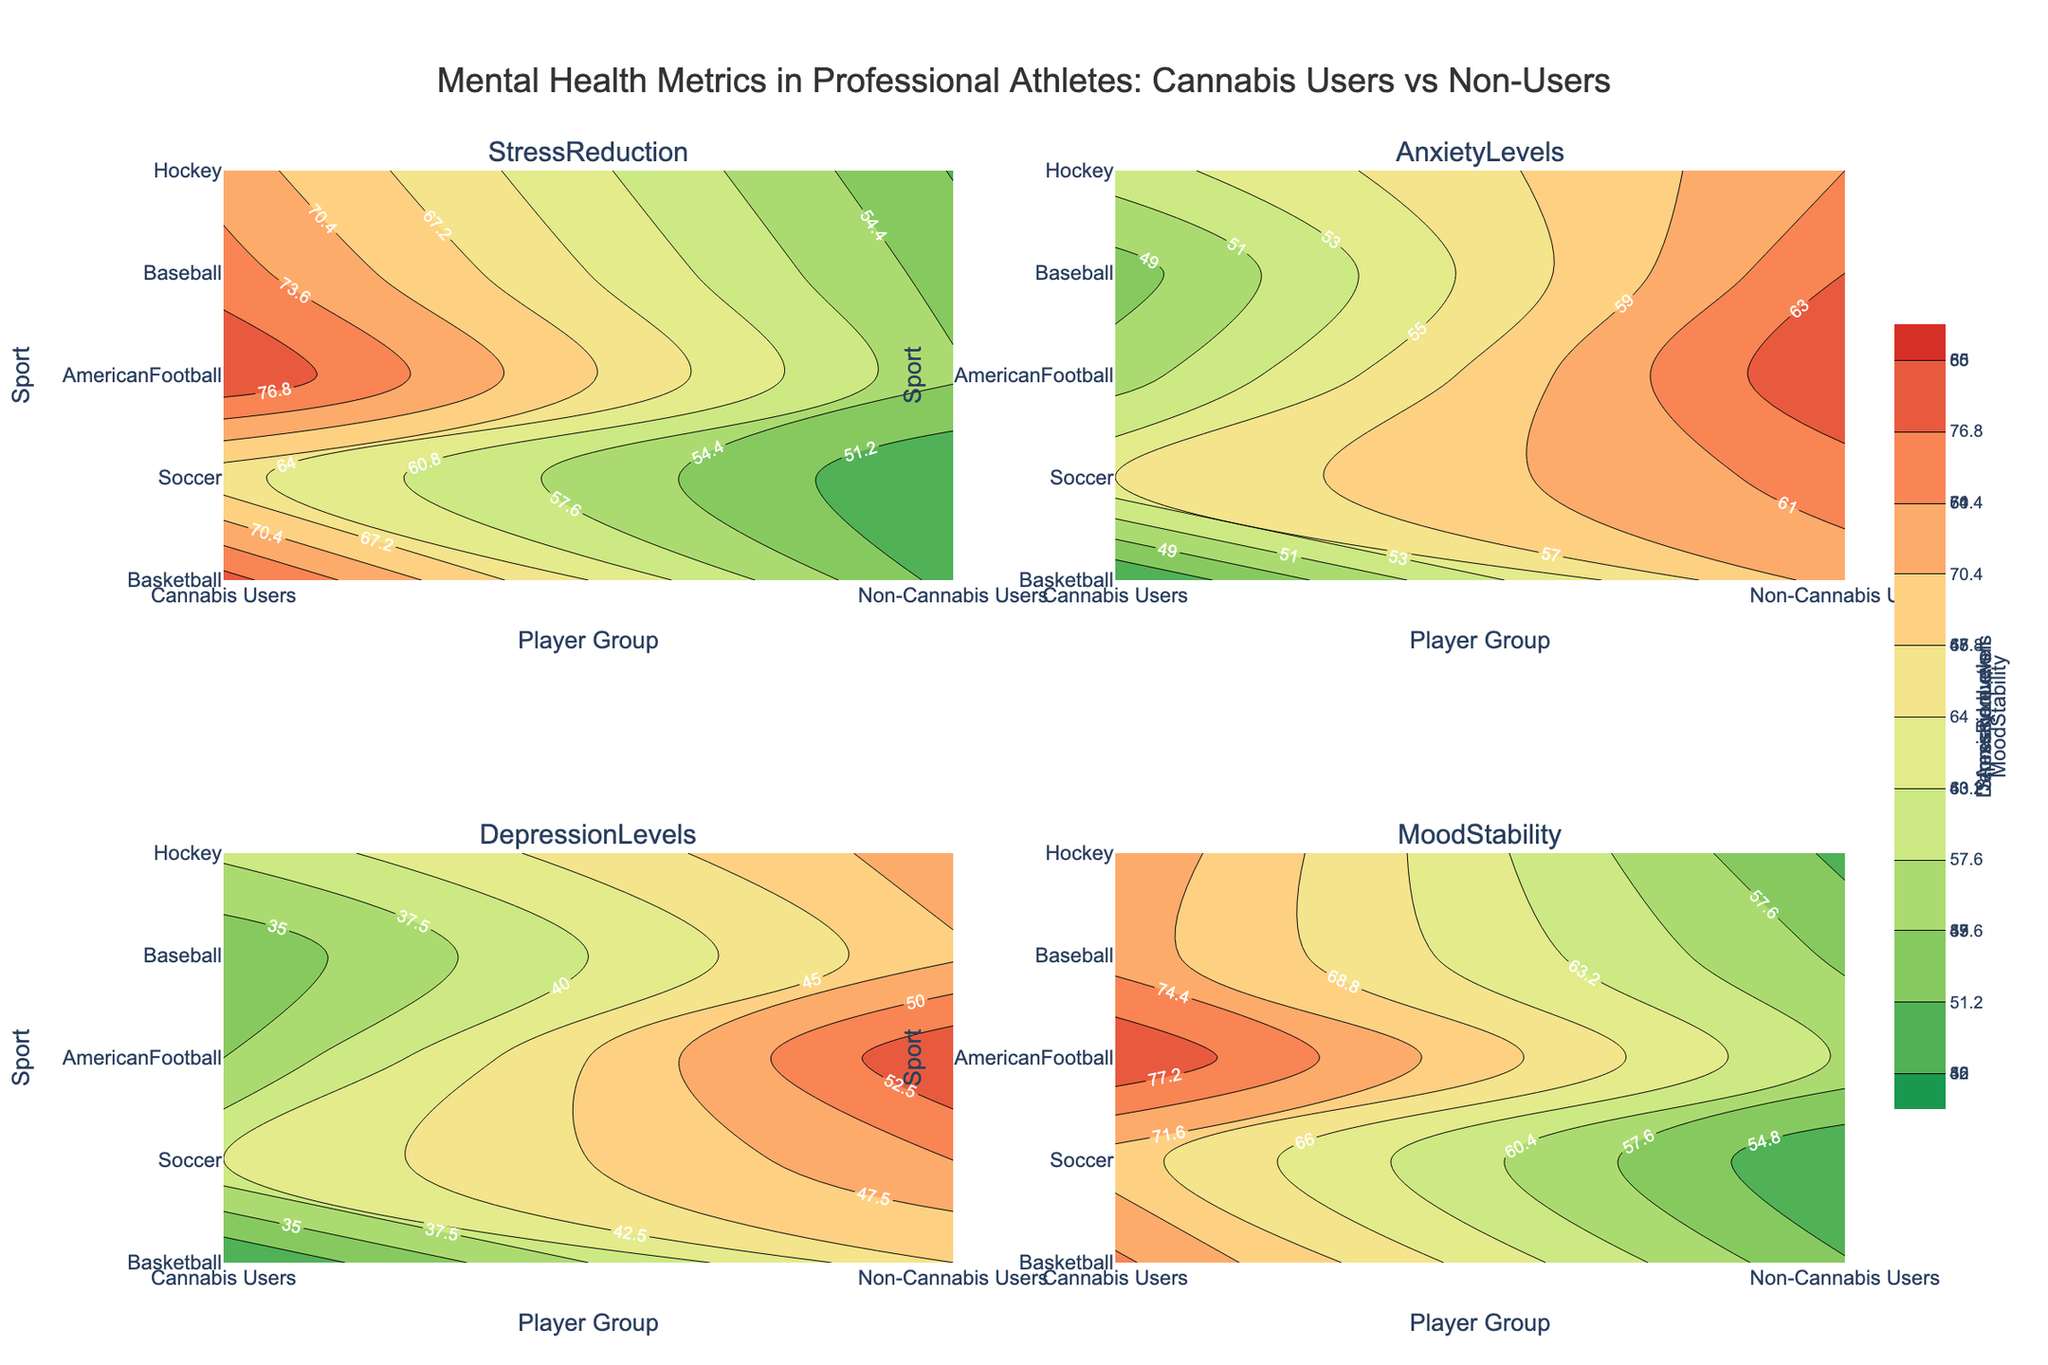What are the four mental health metrics shown in the figure? The figure has subplot titles showing four metrics related to mental health. They are Stress Reduction, Anxiety Levels, Depression Levels, and Mood Stability.
Answer: Stress Reduction, Anxiety Levels, Depression Levels, Mood Stability Which sport shows the highest stress reduction in cannabis users? By examining the contours in the subplot related to Stress Reduction, the sport with the highest stress reduction for cannabis users is American Football, with a value of 80.
Answer: American Football How does the anxiety level of non-cannabis users in Basketball compare to cannabis users in Soccer? From the Anxiety Levels subplot, Basketball non-cannabis users have an anxiety level of 60, while Soccer cannabis users have an anxiety level of 55. Thus, Basketball non-cannabis users have a higher anxiety level.
Answer: Higher Which group has the lowest depression levels across all sports? Looking at the Depression Levels subplot, the lowest values across sports appear in the cannabis users group, specifically in Basketball, with a value of 30.
Answer: Basketball Cannabis Users What is the difference in mood stability between cannabis users and non-cannabis users in Hockey? The Mood Stability subplot shows values for Hockey: cannabis users have a mood stability of 74, while non-cannabis users have a value of 54, making the difference 20.
Answer: 20 In which sport do non-cannabis users have the highest levels of anxiety? The subplot for Anxiety Levels indicates that among non-cannabis users, the highest level of anxiety is in Soccer, with a value of 62.
Answer: Soccer Compare the depression levels in Baseball for both cannabis users and non-cannabis users. Which group fares better? For Baseball, the Depression Levels subplot shows 33 for cannabis users and 47 for non-cannabis users. Cannabis users have lower depression levels.
Answer: Cannabis Users What trend can you observe in Stress Reduction between cannabis users and non-cannabis users across sports? By comparing the Stress Reduction values in each sport, cannabis users have consistently higher stress reduction values than non-cannabis users in all sports shown.
Answer: Higher in Cannabis Users 